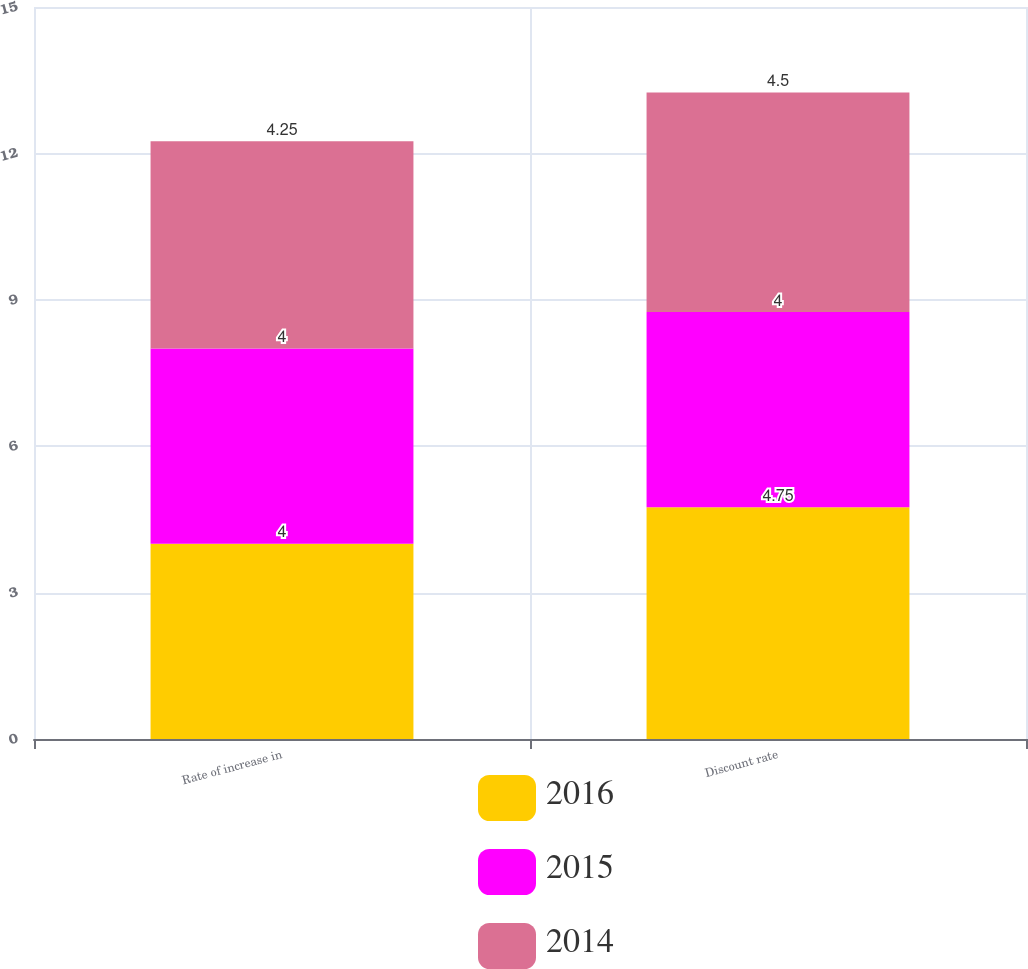Convert chart. <chart><loc_0><loc_0><loc_500><loc_500><stacked_bar_chart><ecel><fcel>Rate of increase in<fcel>Discount rate<nl><fcel>2016<fcel>4<fcel>4.75<nl><fcel>2015<fcel>4<fcel>4<nl><fcel>2014<fcel>4.25<fcel>4.5<nl></chart> 